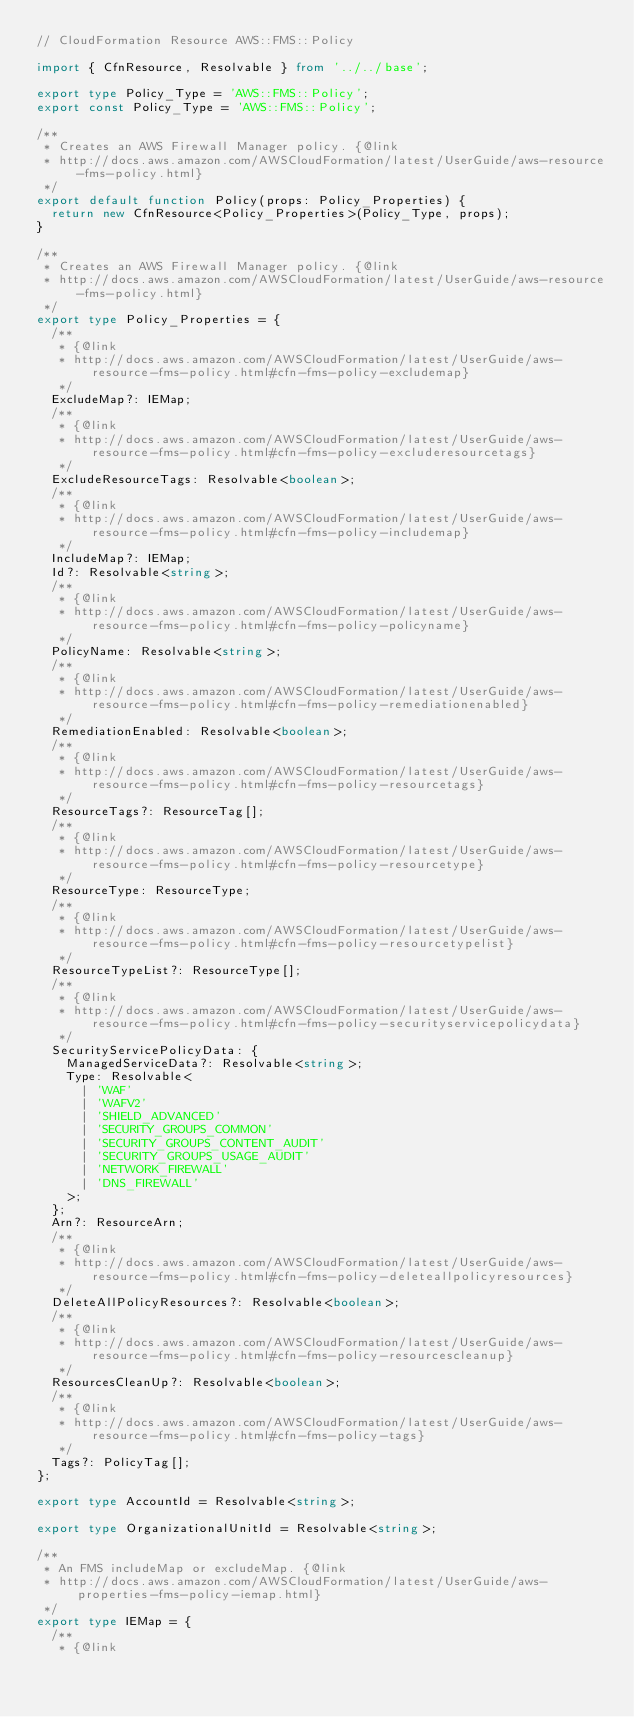<code> <loc_0><loc_0><loc_500><loc_500><_TypeScript_>// CloudFormation Resource AWS::FMS::Policy

import { CfnResource, Resolvable } from '../../base';

export type Policy_Type = 'AWS::FMS::Policy';
export const Policy_Type = 'AWS::FMS::Policy';

/**
 * Creates an AWS Firewall Manager policy. {@link
 * http://docs.aws.amazon.com/AWSCloudFormation/latest/UserGuide/aws-resource-fms-policy.html}
 */
export default function Policy(props: Policy_Properties) {
  return new CfnResource<Policy_Properties>(Policy_Type, props);
}

/**
 * Creates an AWS Firewall Manager policy. {@link
 * http://docs.aws.amazon.com/AWSCloudFormation/latest/UserGuide/aws-resource-fms-policy.html}
 */
export type Policy_Properties = {
  /**
   * {@link
   * http://docs.aws.amazon.com/AWSCloudFormation/latest/UserGuide/aws-resource-fms-policy.html#cfn-fms-policy-excludemap}
   */
  ExcludeMap?: IEMap;
  /**
   * {@link
   * http://docs.aws.amazon.com/AWSCloudFormation/latest/UserGuide/aws-resource-fms-policy.html#cfn-fms-policy-excluderesourcetags}
   */
  ExcludeResourceTags: Resolvable<boolean>;
  /**
   * {@link
   * http://docs.aws.amazon.com/AWSCloudFormation/latest/UserGuide/aws-resource-fms-policy.html#cfn-fms-policy-includemap}
   */
  IncludeMap?: IEMap;
  Id?: Resolvable<string>;
  /**
   * {@link
   * http://docs.aws.amazon.com/AWSCloudFormation/latest/UserGuide/aws-resource-fms-policy.html#cfn-fms-policy-policyname}
   */
  PolicyName: Resolvable<string>;
  /**
   * {@link
   * http://docs.aws.amazon.com/AWSCloudFormation/latest/UserGuide/aws-resource-fms-policy.html#cfn-fms-policy-remediationenabled}
   */
  RemediationEnabled: Resolvable<boolean>;
  /**
   * {@link
   * http://docs.aws.amazon.com/AWSCloudFormation/latest/UserGuide/aws-resource-fms-policy.html#cfn-fms-policy-resourcetags}
   */
  ResourceTags?: ResourceTag[];
  /**
   * {@link
   * http://docs.aws.amazon.com/AWSCloudFormation/latest/UserGuide/aws-resource-fms-policy.html#cfn-fms-policy-resourcetype}
   */
  ResourceType: ResourceType;
  /**
   * {@link
   * http://docs.aws.amazon.com/AWSCloudFormation/latest/UserGuide/aws-resource-fms-policy.html#cfn-fms-policy-resourcetypelist}
   */
  ResourceTypeList?: ResourceType[];
  /**
   * {@link
   * http://docs.aws.amazon.com/AWSCloudFormation/latest/UserGuide/aws-resource-fms-policy.html#cfn-fms-policy-securityservicepolicydata}
   */
  SecurityServicePolicyData: {
    ManagedServiceData?: Resolvable<string>;
    Type: Resolvable<
      | 'WAF'
      | 'WAFV2'
      | 'SHIELD_ADVANCED'
      | 'SECURITY_GROUPS_COMMON'
      | 'SECURITY_GROUPS_CONTENT_AUDIT'
      | 'SECURITY_GROUPS_USAGE_AUDIT'
      | 'NETWORK_FIREWALL'
      | 'DNS_FIREWALL'
    >;
  };
  Arn?: ResourceArn;
  /**
   * {@link
   * http://docs.aws.amazon.com/AWSCloudFormation/latest/UserGuide/aws-resource-fms-policy.html#cfn-fms-policy-deleteallpolicyresources}
   */
  DeleteAllPolicyResources?: Resolvable<boolean>;
  /**
   * {@link
   * http://docs.aws.amazon.com/AWSCloudFormation/latest/UserGuide/aws-resource-fms-policy.html#cfn-fms-policy-resourcescleanup}
   */
  ResourcesCleanUp?: Resolvable<boolean>;
  /**
   * {@link
   * http://docs.aws.amazon.com/AWSCloudFormation/latest/UserGuide/aws-resource-fms-policy.html#cfn-fms-policy-tags}
   */
  Tags?: PolicyTag[];
};

export type AccountId = Resolvable<string>;

export type OrganizationalUnitId = Resolvable<string>;

/**
 * An FMS includeMap or excludeMap. {@link
 * http://docs.aws.amazon.com/AWSCloudFormation/latest/UserGuide/aws-properties-fms-policy-iemap.html}
 */
export type IEMap = {
  /**
   * {@link</code> 